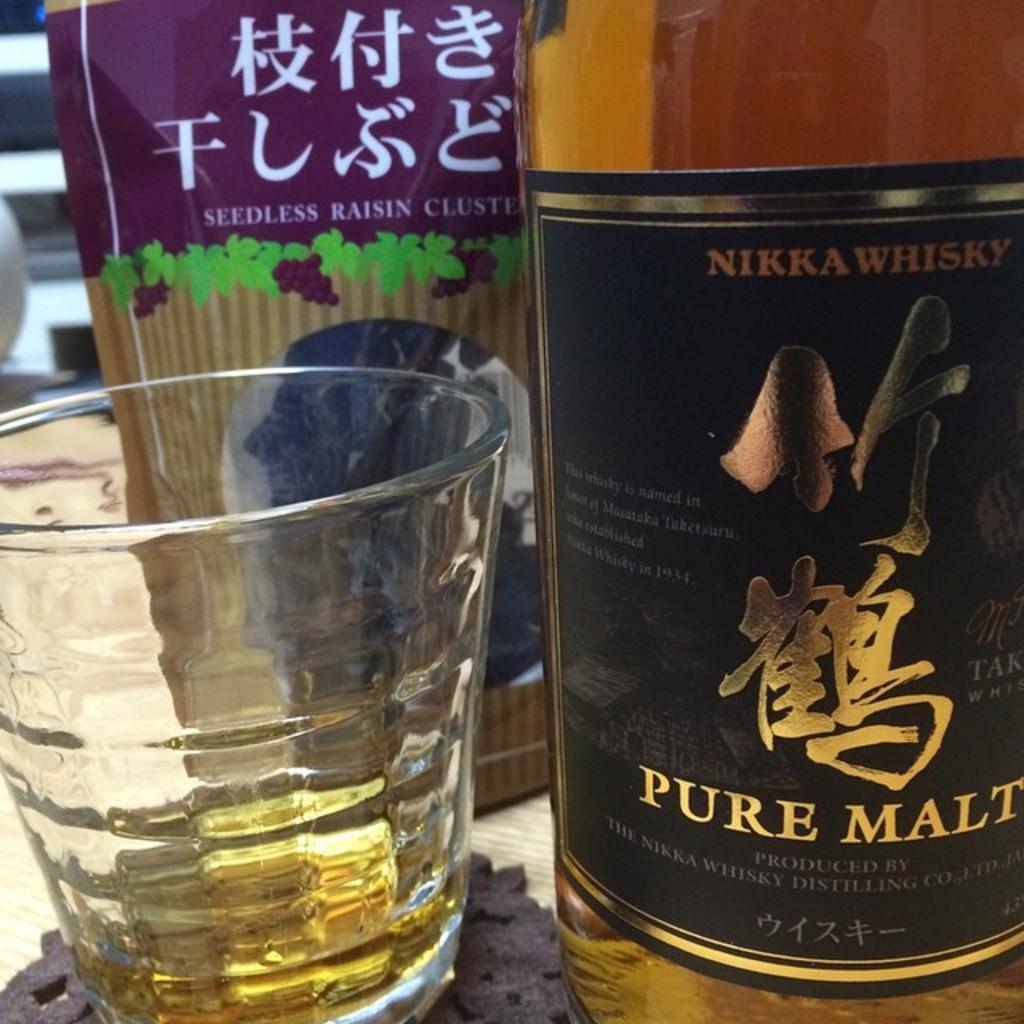Please provide a concise description of this image. In this image I can see a glass bottle and glass. 